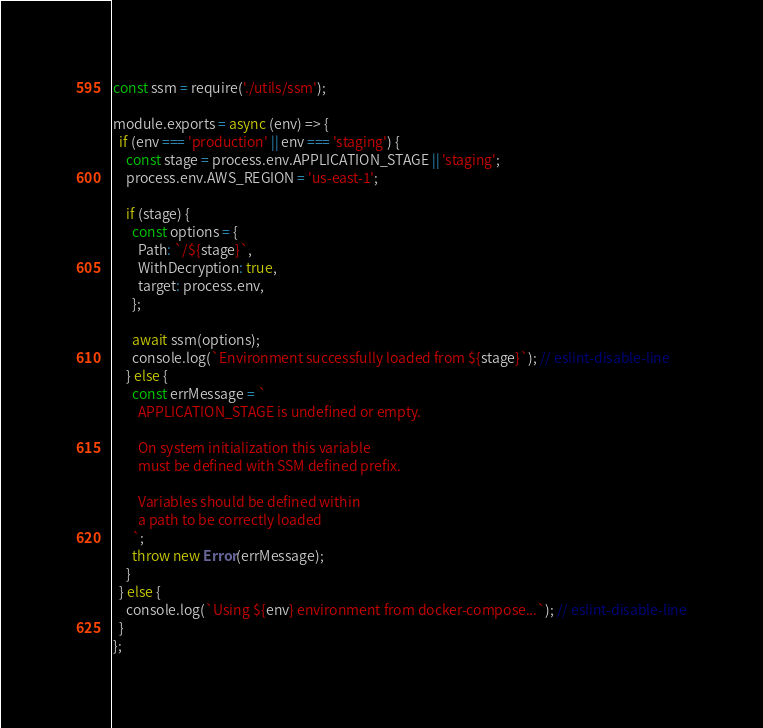Convert code to text. <code><loc_0><loc_0><loc_500><loc_500><_JavaScript_>const ssm = require('./utils/ssm');

module.exports = async (env) => {
  if (env === 'production' || env === 'staging') {
    const stage = process.env.APPLICATION_STAGE || 'staging';
    process.env.AWS_REGION = 'us-east-1';

    if (stage) {
      const options = {
        Path: `/${stage}`,
        WithDecryption: true,
        target: process.env,
      };

      await ssm(options);
      console.log(`Environment successfully loaded from ${stage}`); // eslint-disable-line
    } else {
      const errMessage = `
        APPLICATION_STAGE is undefined or empty.

        On system initialization this variable
        must be defined with SSM defined prefix.

        Variables should be defined within
        a path to be correctly loaded
      `;
      throw new Error(errMessage);
    }
  } else {
    console.log(`Using ${env} environment from docker-compose...`); // eslint-disable-line
  }
};
</code> 